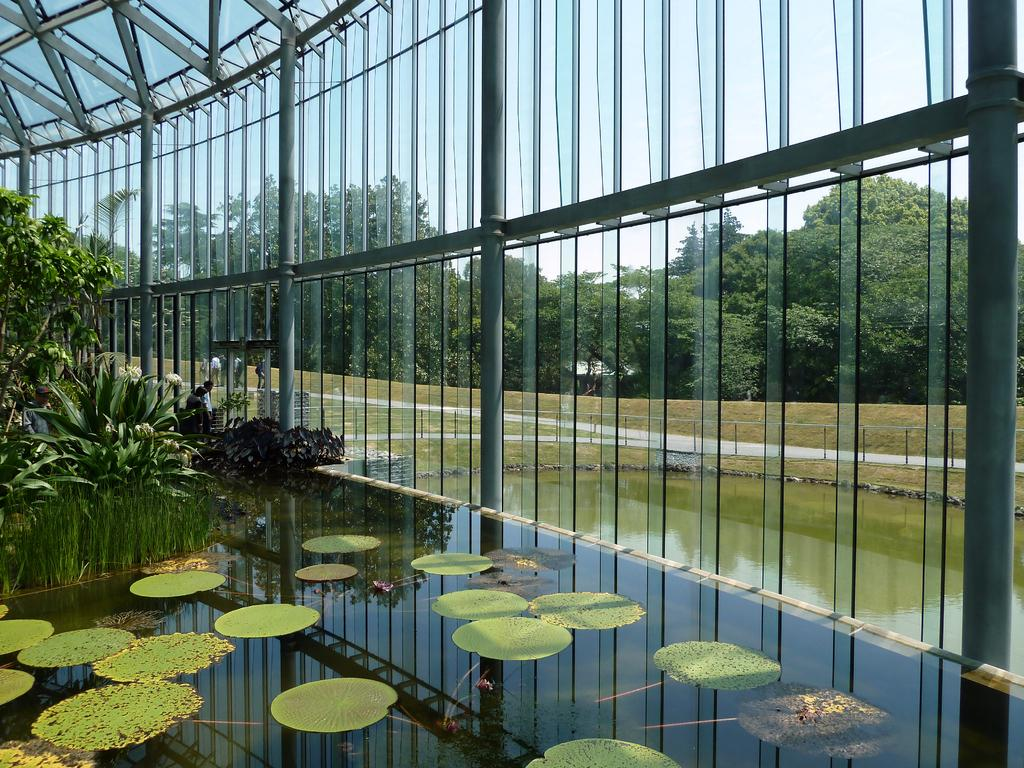What are the people in the image wearing? The people in the image are wearing clothes. What type of vegetation can be seen in the image? There are plants, lotus leaves, and trees visible in the image. What is the water in the image used for? The water in the image is likely used for the plants, as they are often found in or near water sources. What part of the natural environment is visible in the image? The sky is visible in the image. What type of structures are present in the image? There are poles and glass sheets visible in the image. What type of test is being conducted on the father in the image? There is no father or test present in the image; it features people, plants, water, trees, the sky, poles, and glass sheets. 